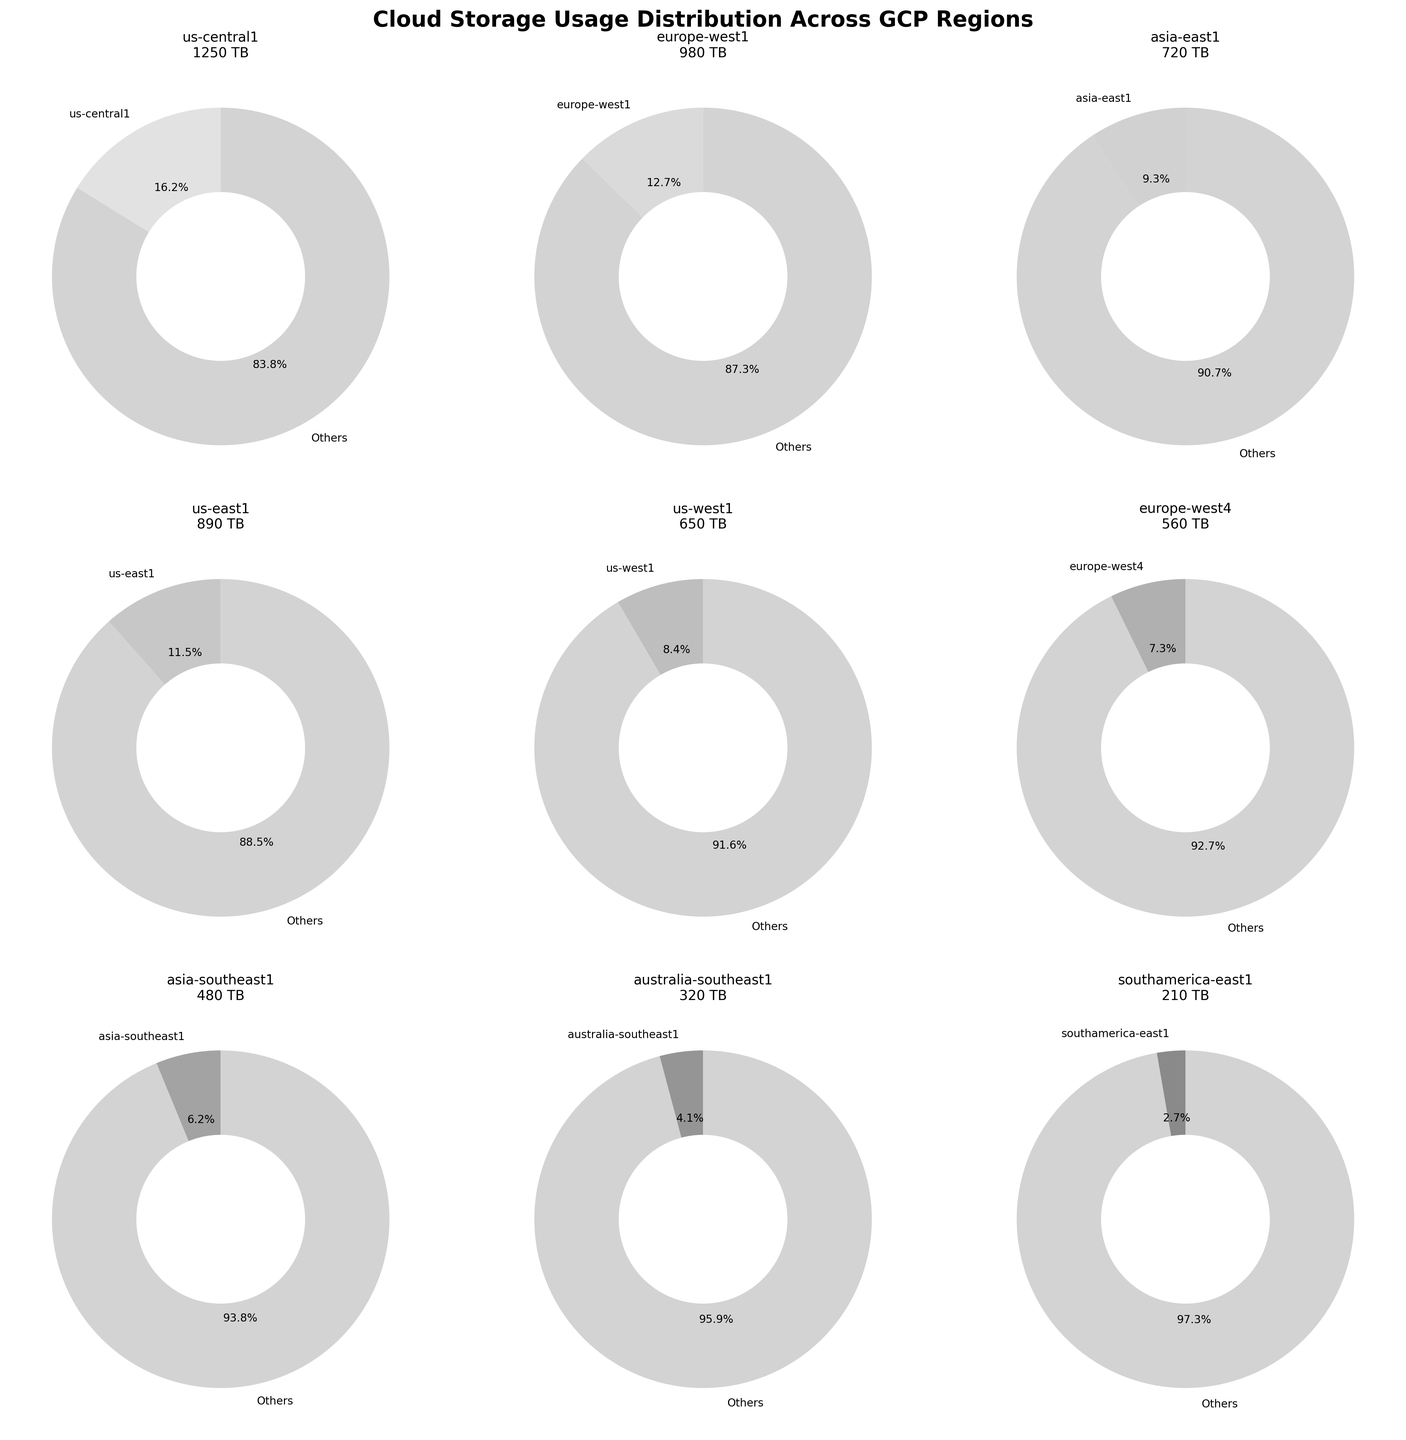What's the title of the figure? The title is usually located at the top of the figure. Reading it directly gives us "Cloud Storage Usage Distribution Across GCP Regions".
Answer: Cloud Storage Usage Distribution Across GCP Regions How many regions are displayed in the pie charts? Each pie chart represents one GCP region. Counting the number of pie charts in the subplot grid gives us the total number of regions.
Answer: 9 Which region has the highest storage usage? By looking at each pie chart and noting the numbers, "us-central1" stands out with the highest storage usage.
Answer: us-central1 What percentage of the total storage usage is used by the 'us-central1' region? The pie chart for 'us-central1' shows a percentage value. This can be read directly from the figure.
Answer: 28.2% What is the combined storage usage for the regions in the first row of the subplot grid? Add the values from the first row (us-central1, europe-west1, asia-east1). Reading off the individual values 1250 TB, 980 TB, and 720 TB and summing them gives 1250 + 980 + 720.
Answer: 2950 TB Which region has a higher storage usage, 'europe-west4' or 'asia-southeast1'? Comparing the pie charts and associated usage values directly, 560 TB for 'europe-west4' and 480 TB for 'asia-southeast1'.
Answer: europe-west4 How does the storage usage of the 'us-west1' region compare to 'europe-west4' and 'asia-southeast1' combined? Sum the values for 'europe-west4' (560 TB) and 'asia-southeast1' (480 TB), which gives 560 + 480. Compare this sum to 'us-west1's value, 650 TB.
Answer: Less Which region in the second row of the subplot grid uses the least storage? Comparing the pie charts in the second row and their usage values (us-east1 - 890 TB, us-west1 - 650 TB, europe-west4 - 560 TB), 'europe-west4' uses the least storage.
Answer: europe-west4 What's the difference in storage usage between 'us-east1' and 'us-west1'? Subtract the storage usage of 'us-west1' (650 TB) from 'us-east1' (890 TB): 890 - 650.
Answer: 240 TB 